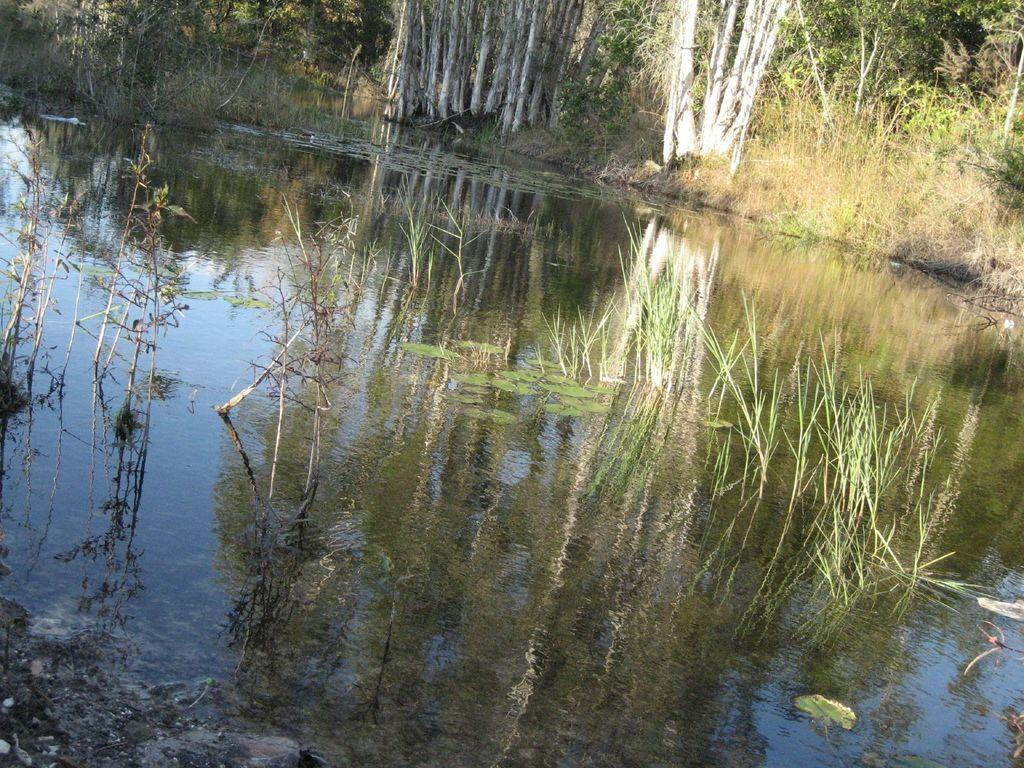What type of water body can be seen in the image? There is a small pond in the image. What surrounds the pond? Tall trees are present around the pond. What is the condition of the grass near the pond? Dry grass is visible around the pond. What type of vegetation is growing in the pond? There are small plants growing in the pond. What type of mitten is the coach wearing in the image? There is no coach or mitten present in the image; it features a small pond surrounded by tall trees and dry grass. 